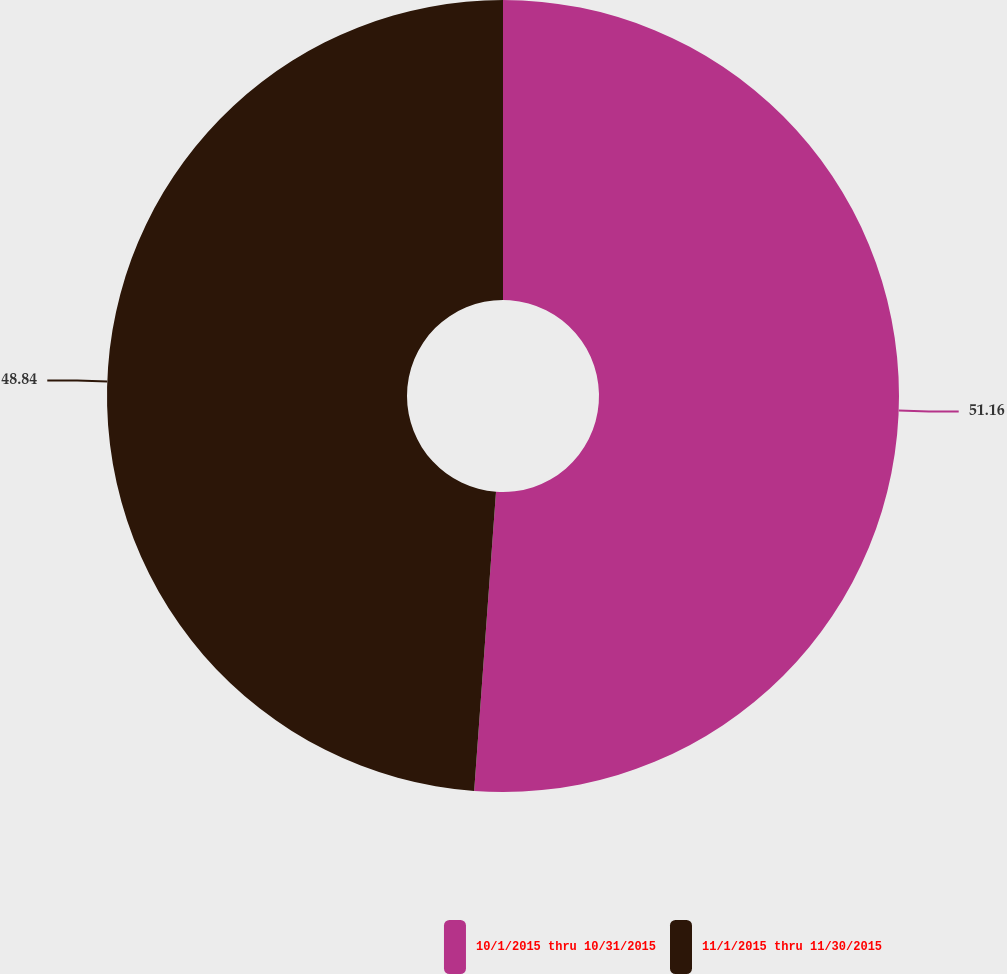<chart> <loc_0><loc_0><loc_500><loc_500><pie_chart><fcel>10/1/2015 thru 10/31/2015<fcel>11/1/2015 thru 11/30/2015<nl><fcel>51.16%<fcel>48.84%<nl></chart> 